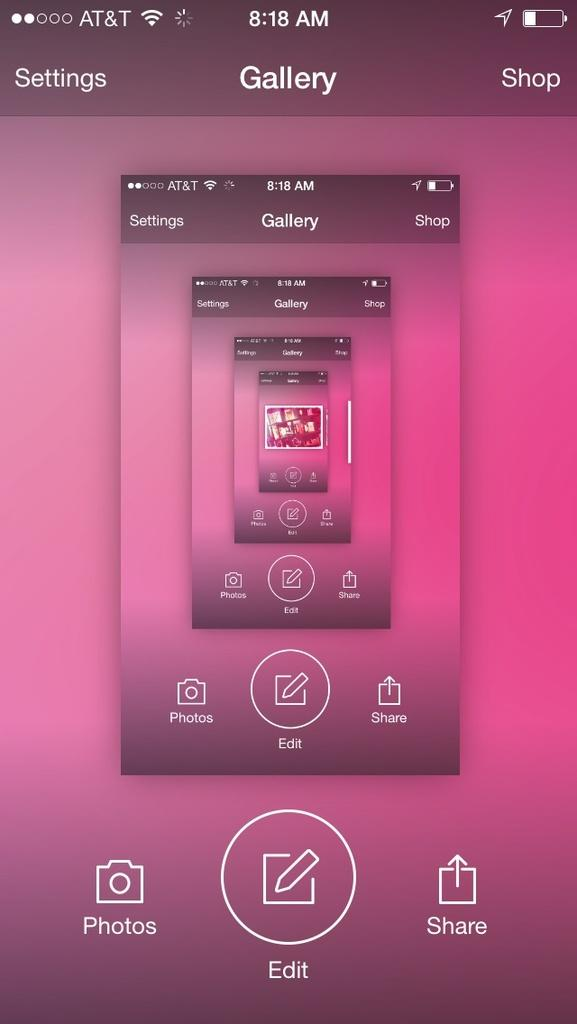What color is the screen of the mobile in the image? The screen is pink. What type of device does the screen belong to? The screen belongs to a mobile. What can be seen on the screen? There are icons on the screen. Is there a chair visible in the image? There is no chair present in the image. Can you see any stitches on the screen of the mobile? There are no stitches visible on the screen of the mobile; it is a digital screen with icons. 